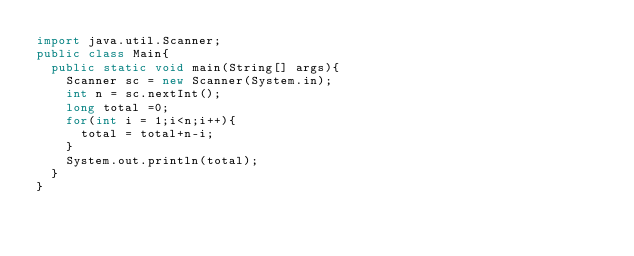Convert code to text. <code><loc_0><loc_0><loc_500><loc_500><_Java_>import java.util.Scanner;
public class Main{
  public static void main(String[] args){
    Scanner sc = new Scanner(System.in);
    int n = sc.nextInt();
    long total =0;
    for(int i = 1;i<n;i++){
      total = total+n-i;
    }
    System.out.println(total);
  }
}
</code> 